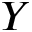Convert formula to latex. <formula><loc_0><loc_0><loc_500><loc_500>Y</formula> 